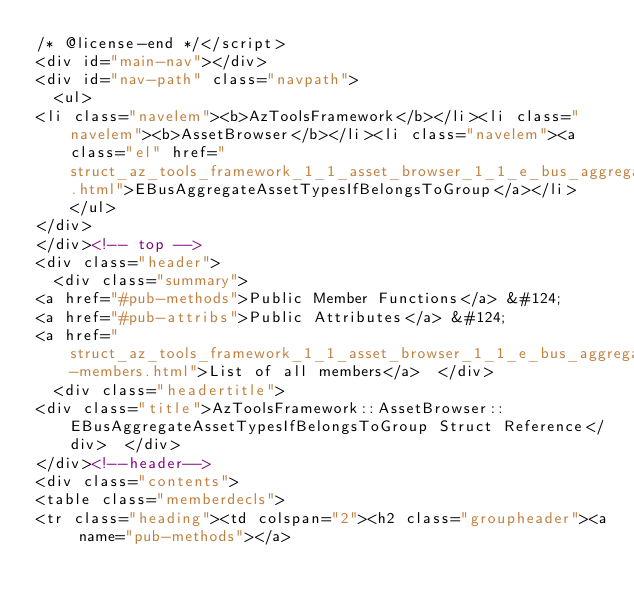Convert code to text. <code><loc_0><loc_0><loc_500><loc_500><_HTML_>/* @license-end */</script>
<div id="main-nav"></div>
<div id="nav-path" class="navpath">
  <ul>
<li class="navelem"><b>AzToolsFramework</b></li><li class="navelem"><b>AssetBrowser</b></li><li class="navelem"><a class="el" href="struct_az_tools_framework_1_1_asset_browser_1_1_e_bus_aggregate_asset_types_if_belongs_to_group.html">EBusAggregateAssetTypesIfBelongsToGroup</a></li>  </ul>
</div>
</div><!-- top -->
<div class="header">
  <div class="summary">
<a href="#pub-methods">Public Member Functions</a> &#124;
<a href="#pub-attribs">Public Attributes</a> &#124;
<a href="struct_az_tools_framework_1_1_asset_browser_1_1_e_bus_aggregate_asset_types_if_belongs_to_group-members.html">List of all members</a>  </div>
  <div class="headertitle">
<div class="title">AzToolsFramework::AssetBrowser::EBusAggregateAssetTypesIfBelongsToGroup Struct Reference</div>  </div>
</div><!--header-->
<div class="contents">
<table class="memberdecls">
<tr class="heading"><td colspan="2"><h2 class="groupheader"><a name="pub-methods"></a></code> 